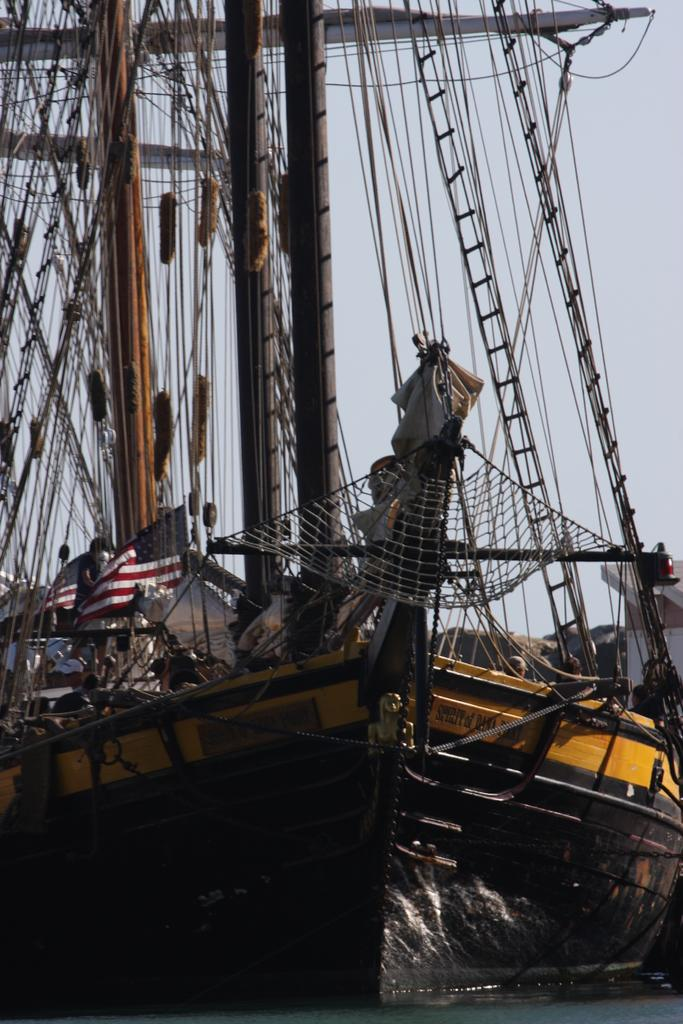What is the main subject of the picture? The main subject of the picture is a ship. What is the ship doing in the picture? The ship is sailing on the water. Are there any additional features attached to the ship? Yes, there are strings attached to the ship. Can you describe the people inside the ship? There are people inside the ship, but their specific actions or roles are not mentioned in the facts. What is the condition of the sky in the picture? The sky is clear in the picture. What type of income can be seen being generated by the ship in the image? There is no indication of income generation in the image; it simply shows a ship sailing on the water with strings attached. What kind of bait is being used by the kitten on the ship in the image? There is no kitten present in the image, so there is no bait being used. 